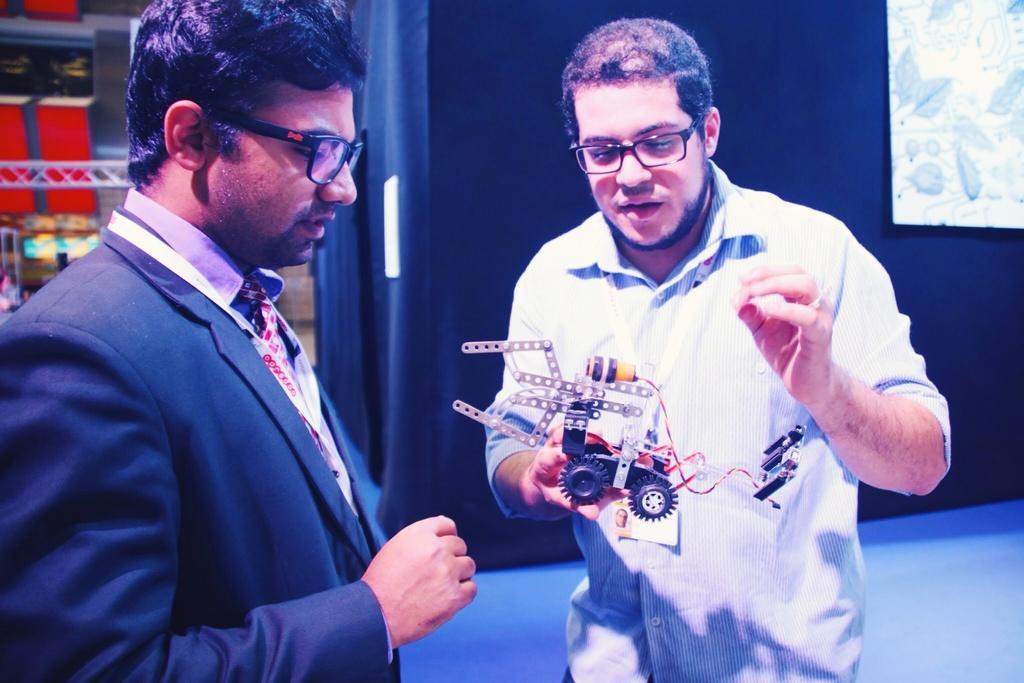In one or two sentences, can you explain what this image depicts? In this image we can see two people standing on the floor. In that a person is holding a motor car. On the backside we can see a wall and a board. 